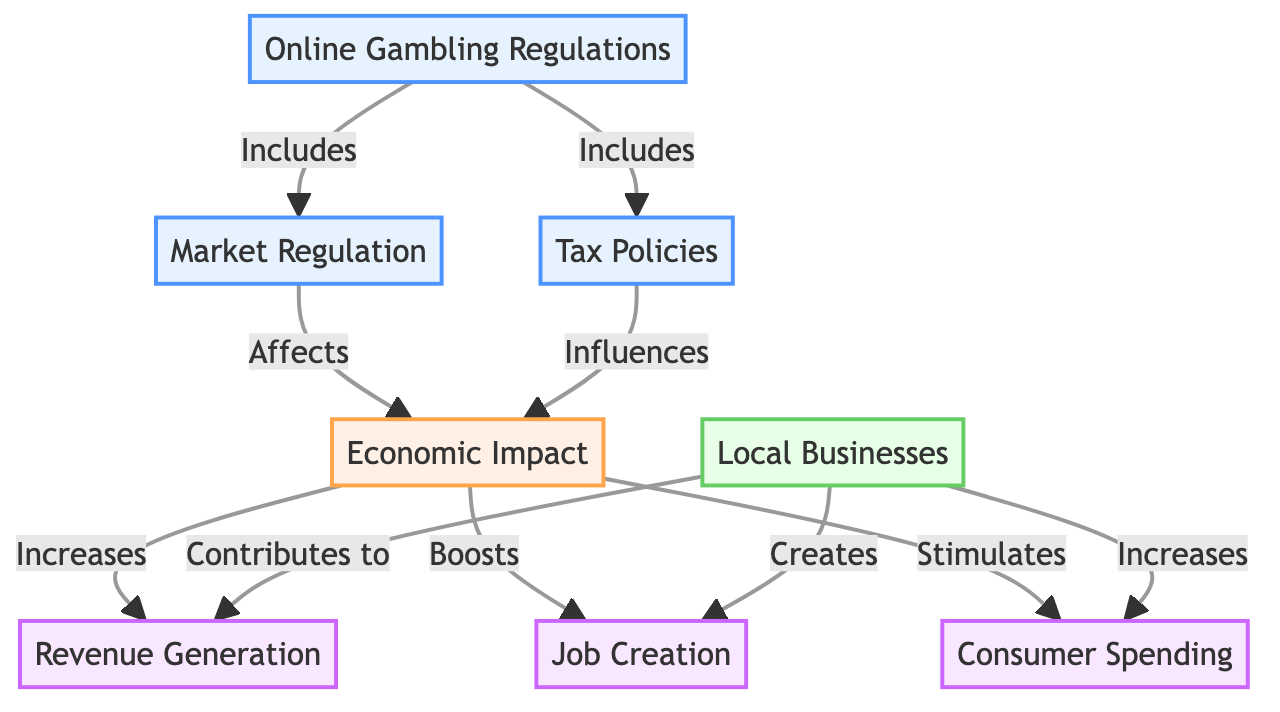What is the primary focus of the diagram? The diagram primarily focuses on the correlation between online gambling regulations and their economic impact on local businesses.
Answer: correlation between online gambling regulations and economic impact on local businesses How many main nodes are present in the diagram? The diagram includes three main nodes: Online Gambling Regulations, Economic Impact, and Local Businesses.
Answer: three What type of relationship exists between 'Online Gambling Regulations' and 'Market Regulation'? The relationship is one of inclusion, indicated by the arrow labeled "Includes" from 'Online Gambling Regulations' to 'Market Regulation'.
Answer: Includes What is one way 'Economic Impact' contributes to 'Local Businesses'? It contributes by creating jobs, as indicated by the arrow labeled "Creates" from 'Economic Impact' to 'Local Businesses'.
Answer: Creates jobs How does 'Tax Policies' influence 'Economic Impact'? 'Tax Policies' influences 'Economic Impact' as indicated by the arrow labeled "Influences" going from 'Tax Policies' to 'Economic Impact'.
Answer: Influences Which indicator is linked to increased consumer spending? The indicator linked to increased consumer spending is 'Consumer Spending', which is affected by 'Economic Impact' in the diagram.
Answer: Consumer Spending What is a possible consequence of 'Economic Impact' on local businesses? The consequence is the generation of revenue, as indicated by the relationship 'Economic Impact' to 'Revenue Generation' which is labeled "Increases".
Answer: Revenue Generation How many relationships link 'Economic Impact' with indicators? There are three relationships linking 'Economic Impact' with indicators: increases revenue generation, boosts job creation, and stimulates consumer spending.
Answer: three Which node directly influences 'Economic Impact'? Both 'Market Regulation' and 'Tax Policies' directly influence 'Economic Impact' as they are connected to it through arrows.
Answer: Market Regulation and Tax Policies 